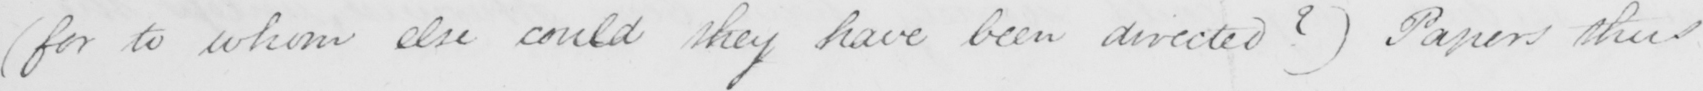Can you read and transcribe this handwriting? ( for to whom else could they have been directed ?  )  Papers thus 